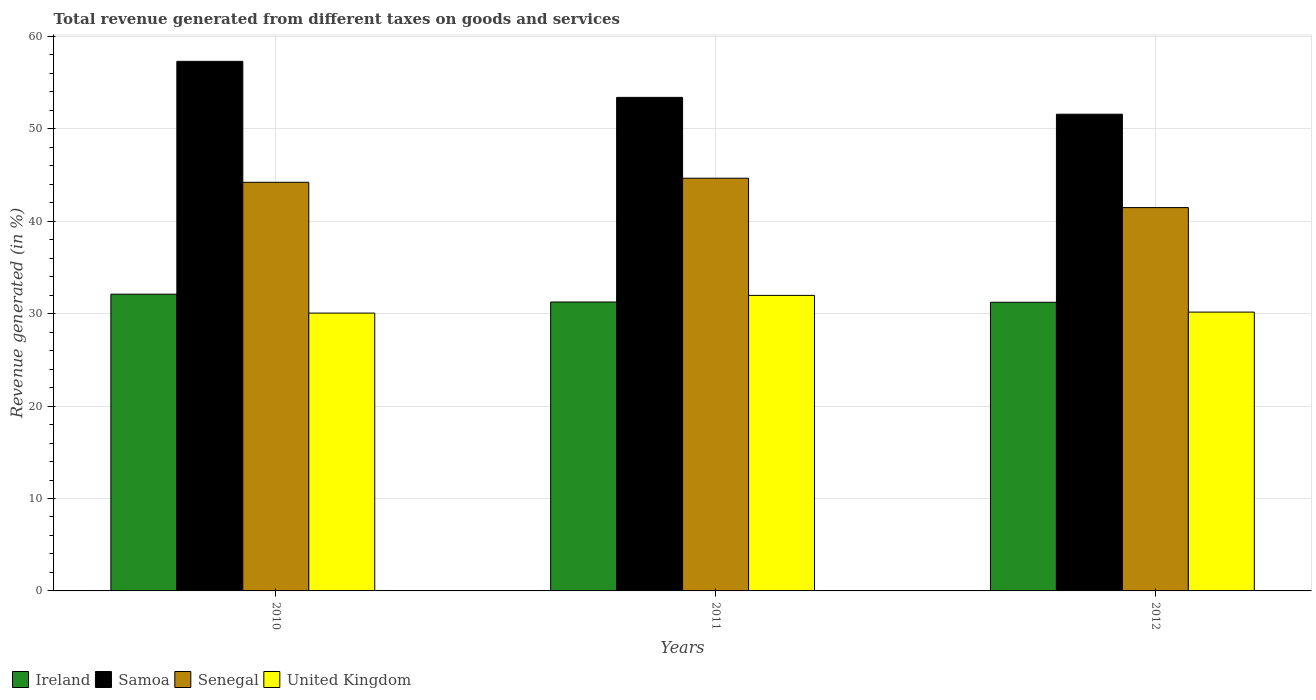How many groups of bars are there?
Give a very brief answer. 3. Are the number of bars per tick equal to the number of legend labels?
Your answer should be very brief. Yes. Are the number of bars on each tick of the X-axis equal?
Keep it short and to the point. Yes. How many bars are there on the 1st tick from the left?
Your answer should be very brief. 4. How many bars are there on the 2nd tick from the right?
Give a very brief answer. 4. What is the label of the 3rd group of bars from the left?
Offer a terse response. 2012. What is the total revenue generated in Samoa in 2010?
Ensure brevity in your answer.  57.31. Across all years, what is the maximum total revenue generated in United Kingdom?
Make the answer very short. 31.98. Across all years, what is the minimum total revenue generated in Ireland?
Ensure brevity in your answer.  31.24. In which year was the total revenue generated in Senegal maximum?
Ensure brevity in your answer.  2011. In which year was the total revenue generated in Ireland minimum?
Keep it short and to the point. 2012. What is the total total revenue generated in Samoa in the graph?
Provide a short and direct response. 162.31. What is the difference between the total revenue generated in Ireland in 2011 and that in 2012?
Offer a terse response. 0.03. What is the difference between the total revenue generated in Samoa in 2011 and the total revenue generated in United Kingdom in 2012?
Your answer should be compact. 23.24. What is the average total revenue generated in Ireland per year?
Your answer should be compact. 31.54. In the year 2010, what is the difference between the total revenue generated in Samoa and total revenue generated in United Kingdom?
Offer a very short reply. 27.25. In how many years, is the total revenue generated in Senegal greater than 38 %?
Provide a short and direct response. 3. What is the ratio of the total revenue generated in Senegal in 2011 to that in 2012?
Provide a short and direct response. 1.08. Is the difference between the total revenue generated in Samoa in 2011 and 2012 greater than the difference between the total revenue generated in United Kingdom in 2011 and 2012?
Ensure brevity in your answer.  Yes. What is the difference between the highest and the second highest total revenue generated in United Kingdom?
Ensure brevity in your answer.  1.81. What is the difference between the highest and the lowest total revenue generated in Samoa?
Keep it short and to the point. 5.72. What does the 3rd bar from the left in 2011 represents?
Give a very brief answer. Senegal. What does the 1st bar from the right in 2012 represents?
Provide a short and direct response. United Kingdom. How many bars are there?
Offer a terse response. 12. Does the graph contain grids?
Provide a succinct answer. Yes. How are the legend labels stacked?
Ensure brevity in your answer.  Horizontal. What is the title of the graph?
Ensure brevity in your answer.  Total revenue generated from different taxes on goods and services. What is the label or title of the Y-axis?
Your response must be concise. Revenue generated (in %). What is the Revenue generated (in %) in Ireland in 2010?
Ensure brevity in your answer.  32.11. What is the Revenue generated (in %) in Samoa in 2010?
Keep it short and to the point. 57.31. What is the Revenue generated (in %) of Senegal in 2010?
Offer a very short reply. 44.22. What is the Revenue generated (in %) of United Kingdom in 2010?
Ensure brevity in your answer.  30.07. What is the Revenue generated (in %) of Ireland in 2011?
Your answer should be compact. 31.27. What is the Revenue generated (in %) in Samoa in 2011?
Your answer should be very brief. 53.41. What is the Revenue generated (in %) in Senegal in 2011?
Ensure brevity in your answer.  44.66. What is the Revenue generated (in %) in United Kingdom in 2011?
Your answer should be very brief. 31.98. What is the Revenue generated (in %) in Ireland in 2012?
Provide a succinct answer. 31.24. What is the Revenue generated (in %) of Samoa in 2012?
Offer a very short reply. 51.59. What is the Revenue generated (in %) of Senegal in 2012?
Offer a very short reply. 41.48. What is the Revenue generated (in %) of United Kingdom in 2012?
Your answer should be very brief. 30.17. Across all years, what is the maximum Revenue generated (in %) in Ireland?
Keep it short and to the point. 32.11. Across all years, what is the maximum Revenue generated (in %) in Samoa?
Offer a terse response. 57.31. Across all years, what is the maximum Revenue generated (in %) in Senegal?
Provide a succinct answer. 44.66. Across all years, what is the maximum Revenue generated (in %) in United Kingdom?
Provide a short and direct response. 31.98. Across all years, what is the minimum Revenue generated (in %) in Ireland?
Offer a terse response. 31.24. Across all years, what is the minimum Revenue generated (in %) in Samoa?
Provide a succinct answer. 51.59. Across all years, what is the minimum Revenue generated (in %) of Senegal?
Offer a very short reply. 41.48. Across all years, what is the minimum Revenue generated (in %) in United Kingdom?
Give a very brief answer. 30.07. What is the total Revenue generated (in %) of Ireland in the graph?
Provide a succinct answer. 94.62. What is the total Revenue generated (in %) in Samoa in the graph?
Ensure brevity in your answer.  162.31. What is the total Revenue generated (in %) of Senegal in the graph?
Provide a short and direct response. 130.37. What is the total Revenue generated (in %) of United Kingdom in the graph?
Give a very brief answer. 92.22. What is the difference between the Revenue generated (in %) in Ireland in 2010 and that in 2011?
Offer a terse response. 0.85. What is the difference between the Revenue generated (in %) in Samoa in 2010 and that in 2011?
Make the answer very short. 3.9. What is the difference between the Revenue generated (in %) of Senegal in 2010 and that in 2011?
Provide a short and direct response. -0.44. What is the difference between the Revenue generated (in %) in United Kingdom in 2010 and that in 2011?
Make the answer very short. -1.92. What is the difference between the Revenue generated (in %) of Ireland in 2010 and that in 2012?
Your answer should be very brief. 0.88. What is the difference between the Revenue generated (in %) in Samoa in 2010 and that in 2012?
Make the answer very short. 5.72. What is the difference between the Revenue generated (in %) of Senegal in 2010 and that in 2012?
Provide a succinct answer. 2.74. What is the difference between the Revenue generated (in %) of United Kingdom in 2010 and that in 2012?
Your answer should be compact. -0.11. What is the difference between the Revenue generated (in %) in Ireland in 2011 and that in 2012?
Make the answer very short. 0.03. What is the difference between the Revenue generated (in %) of Samoa in 2011 and that in 2012?
Provide a short and direct response. 1.82. What is the difference between the Revenue generated (in %) of Senegal in 2011 and that in 2012?
Make the answer very short. 3.18. What is the difference between the Revenue generated (in %) of United Kingdom in 2011 and that in 2012?
Provide a short and direct response. 1.81. What is the difference between the Revenue generated (in %) of Ireland in 2010 and the Revenue generated (in %) of Samoa in 2011?
Your answer should be compact. -21.3. What is the difference between the Revenue generated (in %) of Ireland in 2010 and the Revenue generated (in %) of Senegal in 2011?
Give a very brief answer. -12.55. What is the difference between the Revenue generated (in %) of Ireland in 2010 and the Revenue generated (in %) of United Kingdom in 2011?
Ensure brevity in your answer.  0.13. What is the difference between the Revenue generated (in %) in Samoa in 2010 and the Revenue generated (in %) in Senegal in 2011?
Offer a very short reply. 12.65. What is the difference between the Revenue generated (in %) in Samoa in 2010 and the Revenue generated (in %) in United Kingdom in 2011?
Your response must be concise. 25.33. What is the difference between the Revenue generated (in %) of Senegal in 2010 and the Revenue generated (in %) of United Kingdom in 2011?
Keep it short and to the point. 12.24. What is the difference between the Revenue generated (in %) in Ireland in 2010 and the Revenue generated (in %) in Samoa in 2012?
Your answer should be very brief. -19.48. What is the difference between the Revenue generated (in %) of Ireland in 2010 and the Revenue generated (in %) of Senegal in 2012?
Provide a short and direct response. -9.37. What is the difference between the Revenue generated (in %) of Ireland in 2010 and the Revenue generated (in %) of United Kingdom in 2012?
Offer a terse response. 1.94. What is the difference between the Revenue generated (in %) in Samoa in 2010 and the Revenue generated (in %) in Senegal in 2012?
Your response must be concise. 15.83. What is the difference between the Revenue generated (in %) in Samoa in 2010 and the Revenue generated (in %) in United Kingdom in 2012?
Offer a very short reply. 27.14. What is the difference between the Revenue generated (in %) of Senegal in 2010 and the Revenue generated (in %) of United Kingdom in 2012?
Offer a very short reply. 14.05. What is the difference between the Revenue generated (in %) in Ireland in 2011 and the Revenue generated (in %) in Samoa in 2012?
Give a very brief answer. -20.32. What is the difference between the Revenue generated (in %) in Ireland in 2011 and the Revenue generated (in %) in Senegal in 2012?
Ensure brevity in your answer.  -10.22. What is the difference between the Revenue generated (in %) of Ireland in 2011 and the Revenue generated (in %) of United Kingdom in 2012?
Keep it short and to the point. 1.09. What is the difference between the Revenue generated (in %) in Samoa in 2011 and the Revenue generated (in %) in Senegal in 2012?
Give a very brief answer. 11.93. What is the difference between the Revenue generated (in %) of Samoa in 2011 and the Revenue generated (in %) of United Kingdom in 2012?
Ensure brevity in your answer.  23.24. What is the difference between the Revenue generated (in %) in Senegal in 2011 and the Revenue generated (in %) in United Kingdom in 2012?
Offer a terse response. 14.49. What is the average Revenue generated (in %) of Ireland per year?
Provide a succinct answer. 31.54. What is the average Revenue generated (in %) in Samoa per year?
Keep it short and to the point. 54.1. What is the average Revenue generated (in %) in Senegal per year?
Your answer should be very brief. 43.46. What is the average Revenue generated (in %) in United Kingdom per year?
Offer a terse response. 30.74. In the year 2010, what is the difference between the Revenue generated (in %) of Ireland and Revenue generated (in %) of Samoa?
Give a very brief answer. -25.2. In the year 2010, what is the difference between the Revenue generated (in %) in Ireland and Revenue generated (in %) in Senegal?
Your answer should be compact. -12.11. In the year 2010, what is the difference between the Revenue generated (in %) in Ireland and Revenue generated (in %) in United Kingdom?
Ensure brevity in your answer.  2.05. In the year 2010, what is the difference between the Revenue generated (in %) of Samoa and Revenue generated (in %) of Senegal?
Offer a terse response. 13.09. In the year 2010, what is the difference between the Revenue generated (in %) in Samoa and Revenue generated (in %) in United Kingdom?
Offer a very short reply. 27.25. In the year 2010, what is the difference between the Revenue generated (in %) of Senegal and Revenue generated (in %) of United Kingdom?
Provide a short and direct response. 14.16. In the year 2011, what is the difference between the Revenue generated (in %) of Ireland and Revenue generated (in %) of Samoa?
Your answer should be very brief. -22.14. In the year 2011, what is the difference between the Revenue generated (in %) of Ireland and Revenue generated (in %) of Senegal?
Provide a short and direct response. -13.4. In the year 2011, what is the difference between the Revenue generated (in %) in Ireland and Revenue generated (in %) in United Kingdom?
Keep it short and to the point. -0.72. In the year 2011, what is the difference between the Revenue generated (in %) in Samoa and Revenue generated (in %) in Senegal?
Your response must be concise. 8.75. In the year 2011, what is the difference between the Revenue generated (in %) of Samoa and Revenue generated (in %) of United Kingdom?
Your response must be concise. 21.43. In the year 2011, what is the difference between the Revenue generated (in %) in Senegal and Revenue generated (in %) in United Kingdom?
Give a very brief answer. 12.68. In the year 2012, what is the difference between the Revenue generated (in %) of Ireland and Revenue generated (in %) of Samoa?
Make the answer very short. -20.35. In the year 2012, what is the difference between the Revenue generated (in %) in Ireland and Revenue generated (in %) in Senegal?
Keep it short and to the point. -10.25. In the year 2012, what is the difference between the Revenue generated (in %) in Ireland and Revenue generated (in %) in United Kingdom?
Provide a succinct answer. 1.06. In the year 2012, what is the difference between the Revenue generated (in %) in Samoa and Revenue generated (in %) in Senegal?
Keep it short and to the point. 10.11. In the year 2012, what is the difference between the Revenue generated (in %) of Samoa and Revenue generated (in %) of United Kingdom?
Make the answer very short. 21.42. In the year 2012, what is the difference between the Revenue generated (in %) in Senegal and Revenue generated (in %) in United Kingdom?
Offer a very short reply. 11.31. What is the ratio of the Revenue generated (in %) of Samoa in 2010 to that in 2011?
Give a very brief answer. 1.07. What is the ratio of the Revenue generated (in %) of United Kingdom in 2010 to that in 2011?
Ensure brevity in your answer.  0.94. What is the ratio of the Revenue generated (in %) of Ireland in 2010 to that in 2012?
Provide a succinct answer. 1.03. What is the ratio of the Revenue generated (in %) in Samoa in 2010 to that in 2012?
Ensure brevity in your answer.  1.11. What is the ratio of the Revenue generated (in %) of Senegal in 2010 to that in 2012?
Offer a very short reply. 1.07. What is the ratio of the Revenue generated (in %) of Ireland in 2011 to that in 2012?
Ensure brevity in your answer.  1. What is the ratio of the Revenue generated (in %) of Samoa in 2011 to that in 2012?
Make the answer very short. 1.04. What is the ratio of the Revenue generated (in %) of Senegal in 2011 to that in 2012?
Ensure brevity in your answer.  1.08. What is the ratio of the Revenue generated (in %) in United Kingdom in 2011 to that in 2012?
Your answer should be compact. 1.06. What is the difference between the highest and the second highest Revenue generated (in %) of Ireland?
Ensure brevity in your answer.  0.85. What is the difference between the highest and the second highest Revenue generated (in %) in Samoa?
Your response must be concise. 3.9. What is the difference between the highest and the second highest Revenue generated (in %) in Senegal?
Provide a succinct answer. 0.44. What is the difference between the highest and the second highest Revenue generated (in %) in United Kingdom?
Your answer should be compact. 1.81. What is the difference between the highest and the lowest Revenue generated (in %) of Ireland?
Offer a very short reply. 0.88. What is the difference between the highest and the lowest Revenue generated (in %) of Samoa?
Make the answer very short. 5.72. What is the difference between the highest and the lowest Revenue generated (in %) of Senegal?
Offer a very short reply. 3.18. What is the difference between the highest and the lowest Revenue generated (in %) of United Kingdom?
Your answer should be compact. 1.92. 